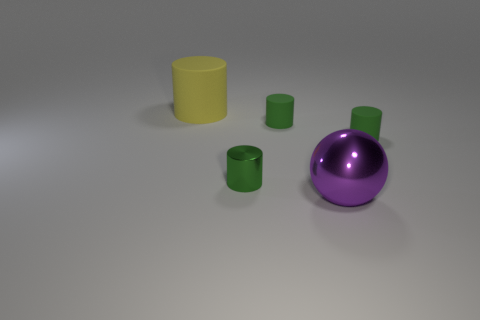What materials do the objects look like they are made of? Based on their visual characteristics, the objects seem to be made of a matte rubber-like material, which gives them a non-reflective surface. 